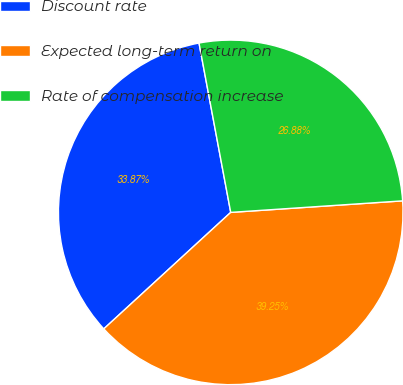Convert chart. <chart><loc_0><loc_0><loc_500><loc_500><pie_chart><fcel>Discount rate<fcel>Expected long-term return on<fcel>Rate of compensation increase<nl><fcel>33.87%<fcel>39.25%<fcel>26.88%<nl></chart> 